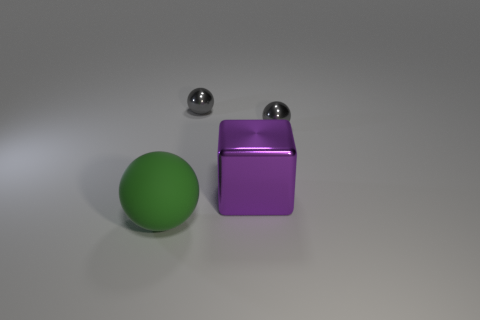Is the size of the shiny sphere left of the block the same as the big green matte sphere?
Make the answer very short. No. How many other things are there of the same size as the purple shiny block?
Your answer should be very brief. 1. What is the color of the big matte sphere?
Offer a very short reply. Green. There is a big thing that is behind the big matte ball; what is its material?
Keep it short and to the point. Metal. Are there an equal number of big green matte spheres that are to the right of the big green ball and green spheres?
Ensure brevity in your answer.  No. What is the shape of the thing that is to the left of the large purple object and behind the big block?
Give a very brief answer. Sphere. Are there the same number of tiny gray metallic things that are in front of the purple block and metal spheres behind the green matte ball?
Ensure brevity in your answer.  No. What number of cubes are either large green things or small metallic things?
Provide a succinct answer. 0. How many big purple blocks have the same material as the green object?
Your answer should be compact. 0. The ball that is behind the purple metal object and left of the big purple metal cube is made of what material?
Offer a terse response. Metal. 